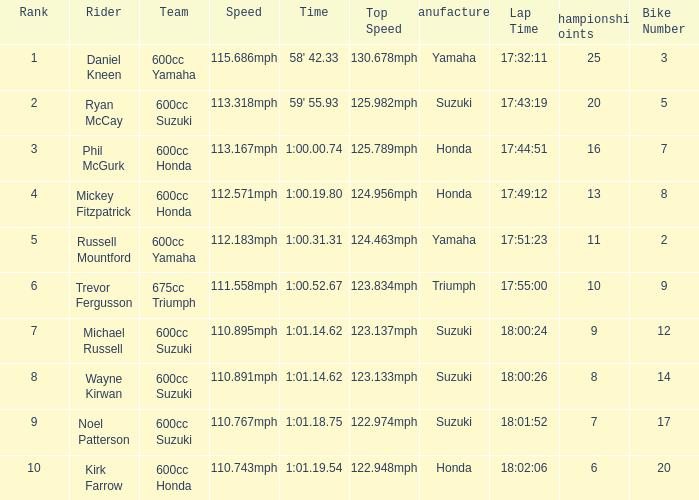Could you help me parse every detail presented in this table? {'header': ['Rank', 'Rider', 'Team', 'Speed', 'Time', 'Top Speed', 'Manufacturer', 'Lap Time', 'Championship Points', 'Bike Number'], 'rows': [['1', 'Daniel Kneen', '600cc Yamaha', '115.686mph', "58' 42.33", '130.678mph', 'Yamaha', '17:32:11', '25', '3'], ['2', 'Ryan McCay', '600cc Suzuki', '113.318mph', "59' 55.93", '125.982mph', 'Suzuki', '17:43:19', '20', '5'], ['3', 'Phil McGurk', '600cc Honda', '113.167mph', '1:00.00.74', '125.789mph', 'Honda', '17:44:51', '16', '7'], ['4', 'Mickey Fitzpatrick', '600cc Honda', '112.571mph', '1:00.19.80', '124.956mph', 'Honda', '17:49:12', '13', '8'], ['5', 'Russell Mountford', '600cc Yamaha', '112.183mph', '1:00.31.31', '124.463mph', 'Yamaha', '17:51:23', '11', '2'], ['6', 'Trevor Fergusson', '675cc Triumph', '111.558mph', '1:00.52.67', '123.834mph', 'Triumph', '17:55:00', '10', '9'], ['7', 'Michael Russell', '600cc Suzuki', '110.895mph', '1:01.14.62', '123.137mph', 'Suzuki', '18:00:24', '9', '12'], ['8', 'Wayne Kirwan', '600cc Suzuki', '110.891mph', '1:01.14.62', '123.133mph', 'Suzuki', '18:00:26', '8', '14'], ['9', 'Noel Patterson', '600cc Suzuki', '110.767mph', '1:01.18.75', '122.974mph', 'Suzuki', '18:01:52', '7', '17'], ['10', 'Kirk Farrow', '600cc Honda', '110.743mph', '1:01.19.54', '122.948mph', 'Honda', '18:02:06', '6', '20']]} How many ranks have 1:01.14.62 as the time, with michael russell as the rider? 1.0. 